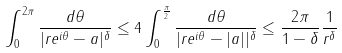<formula> <loc_0><loc_0><loc_500><loc_500>\int _ { 0 } ^ { 2 \pi } \frac { d \theta } { | r e ^ { i \theta } - a | ^ { \delta } } \leq 4 \int _ { 0 } ^ { \frac { \pi } { 2 } } \frac { d \theta } { | r e ^ { i \theta } - | a | | ^ { \delta } } \leq \frac { 2 \pi } { 1 - \delta } \frac { 1 } { r ^ { \delta } }</formula> 